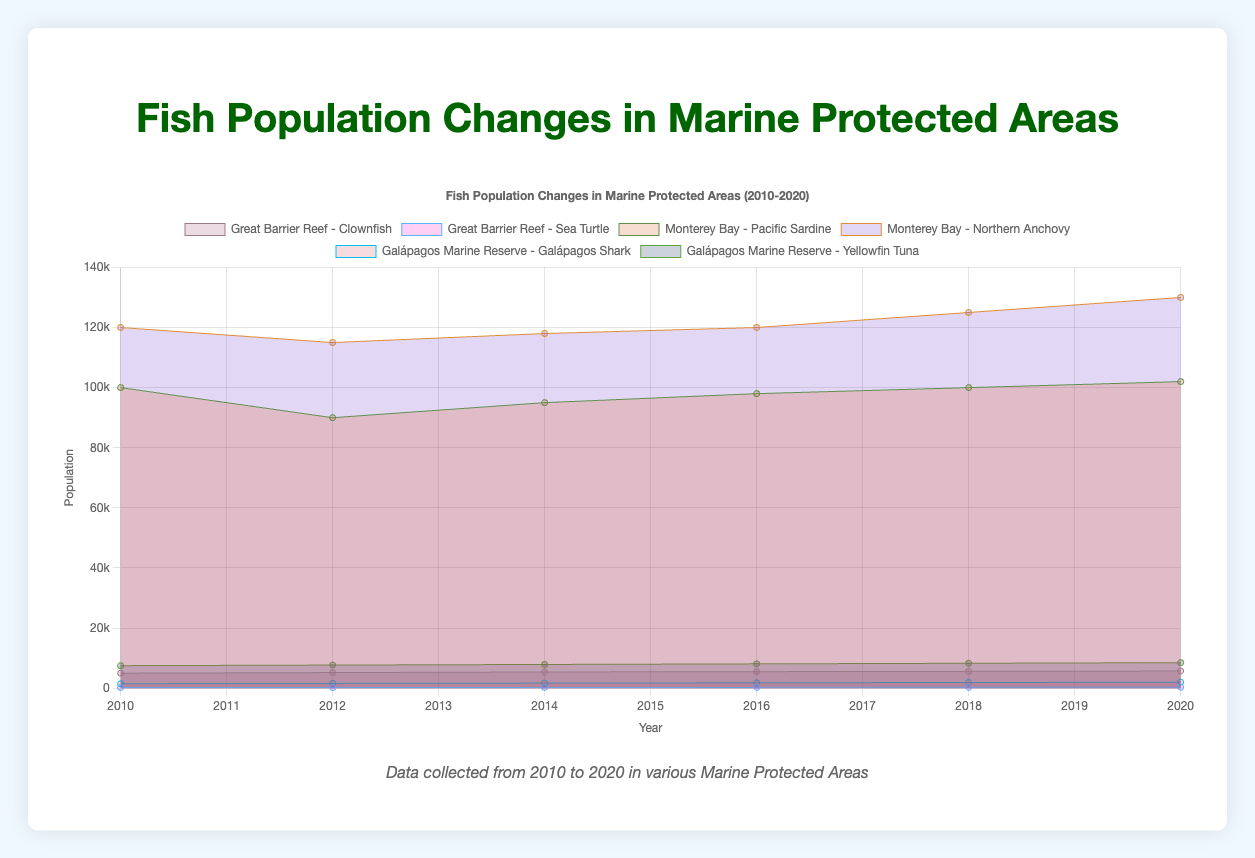What is the title of the chart? The title is prominently displayed at the top of the chart.
Answer: Fish Population Changes in Marine Protected Areas (2010-2020) Which species had the highest population in 2010? From the figure, the population of each species in 2010 can be compared visually; Monterrey Bay's Northern Anchovy had the highest population.
Answer: Northern Anchovy Did the population of Clownfish in the Great Barrier Reef increase or decrease over time? By observing the trend of the Clownfish’s population data, we can see an upward slope from 2010 to 2020, indicating an increase.
Answer: Increase Which area had the most significant increase in fish population over the given time period? To determine this, compute the change in population for each species; the Northern Anchovy in Monterey Bay had the largest increase from 120,000 in 2010 to 130,000 in 2020.
Answer: Monterey Bay What is the average population of the Yellowfin Tuna over the observed decade? Add the population values for each year (7500 + 7700 + 7900 + 8100 + 8300 + 8500) and then divide by the number of years (6). The average is 48,000 divided by 6.
Answer: 8000 Between the Galápagos Shark and the Yellowfin Tuna in the Galápagos Marine Reserve, which species had a higher population in 2020? By comparing the population of the two species in 2020, the Yellowfin Tuna had a population of 8500 while the Galápagos Shark had a population of 2000.
Answer: Yellowfin Tuna What year did the Sea Turtle population in the Great Barrier Reef exceed 250? By examining the increase in population, 2014 is the first year where the population data exceeds 250.
Answer: 2014 Which species in Monterey Bay showed more stability in its population size between 2010 and 2020? Comparing the trends of Pacific Sardine and Northern Anchovy, the Pacific Sardine shows less fluctuation and a steadier trend.
Answer: Pacific Sardine What is the percentage increase in population for the Galápagos Shark from 2010 to 2020? Calculate the difference (2000 - 1500 = 500), and then divide by the original population (500/1500) and multiply by 100 to get the percentage.
Answer: 33.3% What overall trend can be observed for fish populations in marine protected areas over the period from 2010 to 2020? Analyzing the slopes and upward trends of most species' population lines, it is seen that there is an overall increase in fish populations in these areas.
Answer: Overall increase 